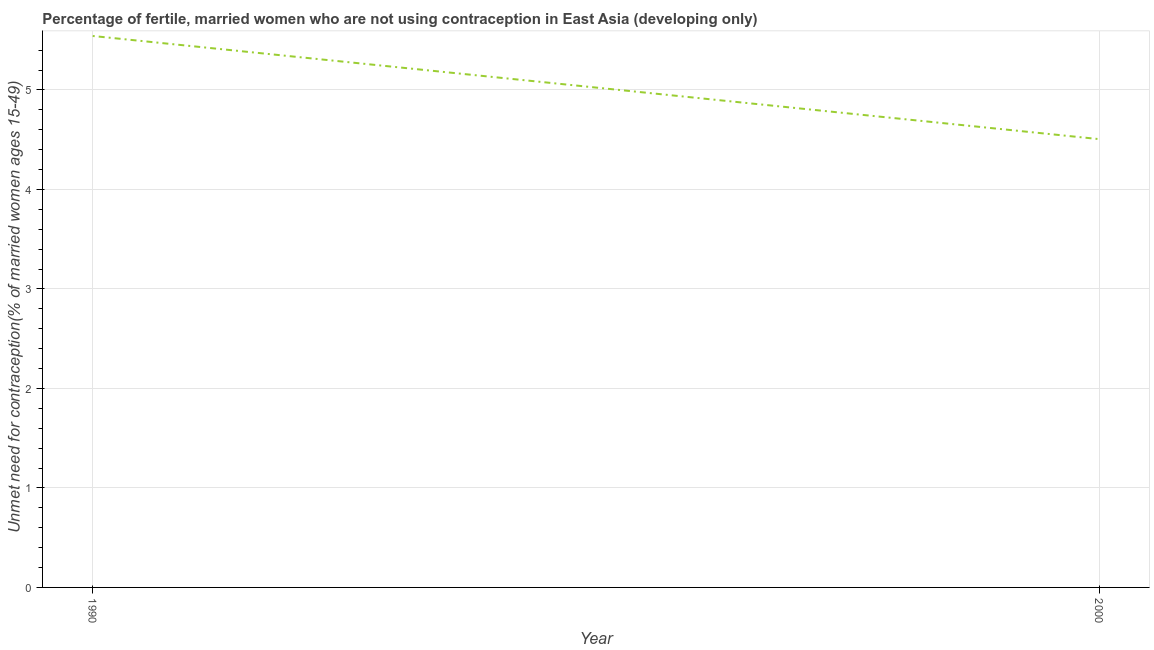What is the number of married women who are not using contraception in 2000?
Your answer should be very brief. 4.51. Across all years, what is the maximum number of married women who are not using contraception?
Provide a short and direct response. 5.54. Across all years, what is the minimum number of married women who are not using contraception?
Offer a terse response. 4.51. What is the sum of the number of married women who are not using contraception?
Provide a succinct answer. 10.05. What is the difference between the number of married women who are not using contraception in 1990 and 2000?
Provide a short and direct response. 1.04. What is the average number of married women who are not using contraception per year?
Your answer should be compact. 5.02. What is the median number of married women who are not using contraception?
Offer a very short reply. 5.02. What is the ratio of the number of married women who are not using contraception in 1990 to that in 2000?
Provide a short and direct response. 1.23. In how many years, is the number of married women who are not using contraception greater than the average number of married women who are not using contraception taken over all years?
Offer a very short reply. 1. Does the number of married women who are not using contraception monotonically increase over the years?
Offer a terse response. No. How many lines are there?
Ensure brevity in your answer.  1. How many years are there in the graph?
Keep it short and to the point. 2. Are the values on the major ticks of Y-axis written in scientific E-notation?
Make the answer very short. No. Does the graph contain any zero values?
Your answer should be very brief. No. What is the title of the graph?
Provide a short and direct response. Percentage of fertile, married women who are not using contraception in East Asia (developing only). What is the label or title of the Y-axis?
Ensure brevity in your answer.   Unmet need for contraception(% of married women ages 15-49). What is the  Unmet need for contraception(% of married women ages 15-49) in 1990?
Your response must be concise. 5.54. What is the  Unmet need for contraception(% of married women ages 15-49) of 2000?
Provide a short and direct response. 4.51. What is the difference between the  Unmet need for contraception(% of married women ages 15-49) in 1990 and 2000?
Ensure brevity in your answer.  1.04. What is the ratio of the  Unmet need for contraception(% of married women ages 15-49) in 1990 to that in 2000?
Your response must be concise. 1.23. 